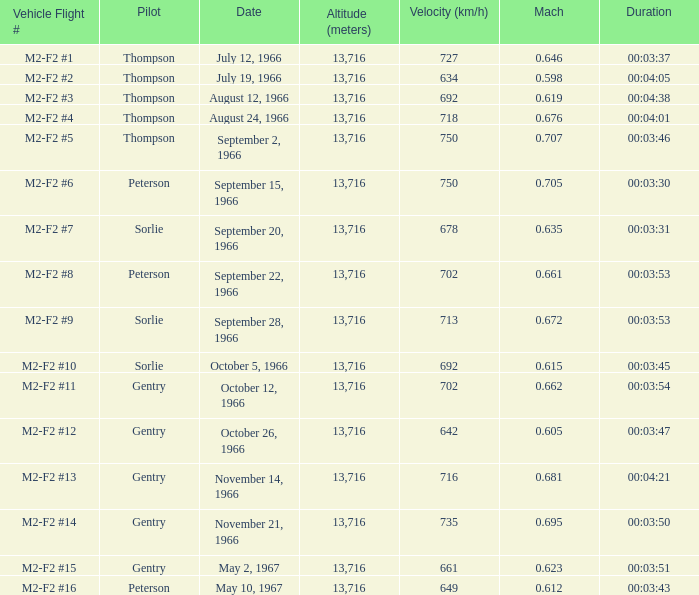What Vehicle Flight # has Pilot Peterson and Velocity (km/h) of 649? M2-F2 #16. 